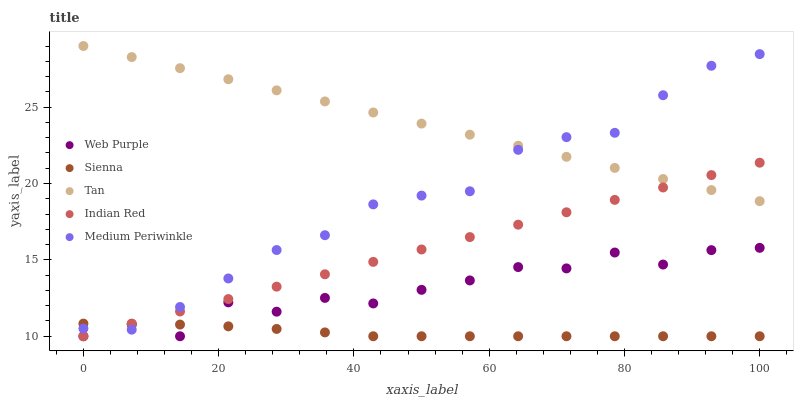Does Sienna have the minimum area under the curve?
Answer yes or no. Yes. Does Tan have the maximum area under the curve?
Answer yes or no. Yes. Does Web Purple have the minimum area under the curve?
Answer yes or no. No. Does Web Purple have the maximum area under the curve?
Answer yes or no. No. Is Indian Red the smoothest?
Answer yes or no. Yes. Is Web Purple the roughest?
Answer yes or no. Yes. Is Medium Periwinkle the smoothest?
Answer yes or no. No. Is Medium Periwinkle the roughest?
Answer yes or no. No. Does Sienna have the lowest value?
Answer yes or no. Yes. Does Medium Periwinkle have the lowest value?
Answer yes or no. No. Does Tan have the highest value?
Answer yes or no. Yes. Does Web Purple have the highest value?
Answer yes or no. No. Is Sienna less than Tan?
Answer yes or no. Yes. Is Tan greater than Web Purple?
Answer yes or no. Yes. Does Web Purple intersect Indian Red?
Answer yes or no. Yes. Is Web Purple less than Indian Red?
Answer yes or no. No. Is Web Purple greater than Indian Red?
Answer yes or no. No. Does Sienna intersect Tan?
Answer yes or no. No. 